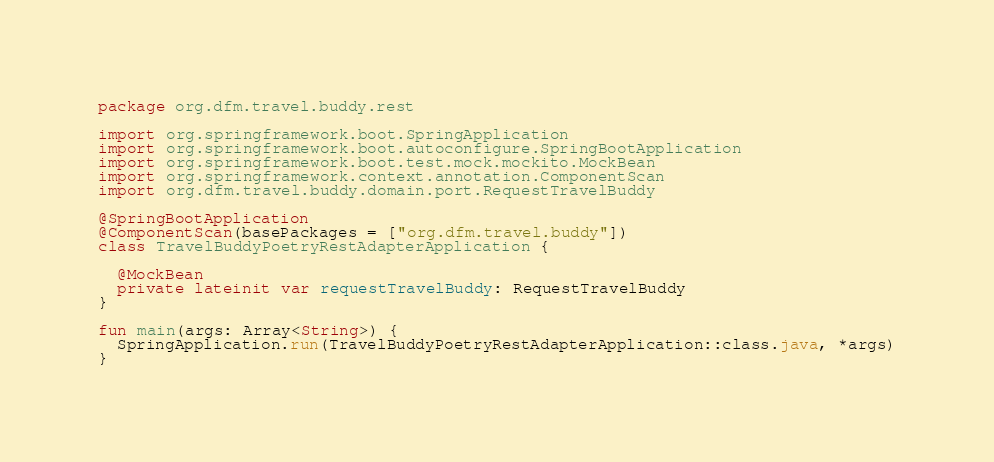<code> <loc_0><loc_0><loc_500><loc_500><_Kotlin_>package org.dfm.travel.buddy.rest

import org.springframework.boot.SpringApplication
import org.springframework.boot.autoconfigure.SpringBootApplication
import org.springframework.boot.test.mock.mockito.MockBean
import org.springframework.context.annotation.ComponentScan
import org.dfm.travel.buddy.domain.port.RequestTravelBuddy

@SpringBootApplication
@ComponentScan(basePackages = ["org.dfm.travel.buddy"])
class TravelBuddyPoetryRestAdapterApplication {

  @MockBean
  private lateinit var requestTravelBuddy: RequestTravelBuddy
}

fun main(args: Array<String>) {
  SpringApplication.run(TravelBuddyPoetryRestAdapterApplication::class.java, *args)
}
</code> 